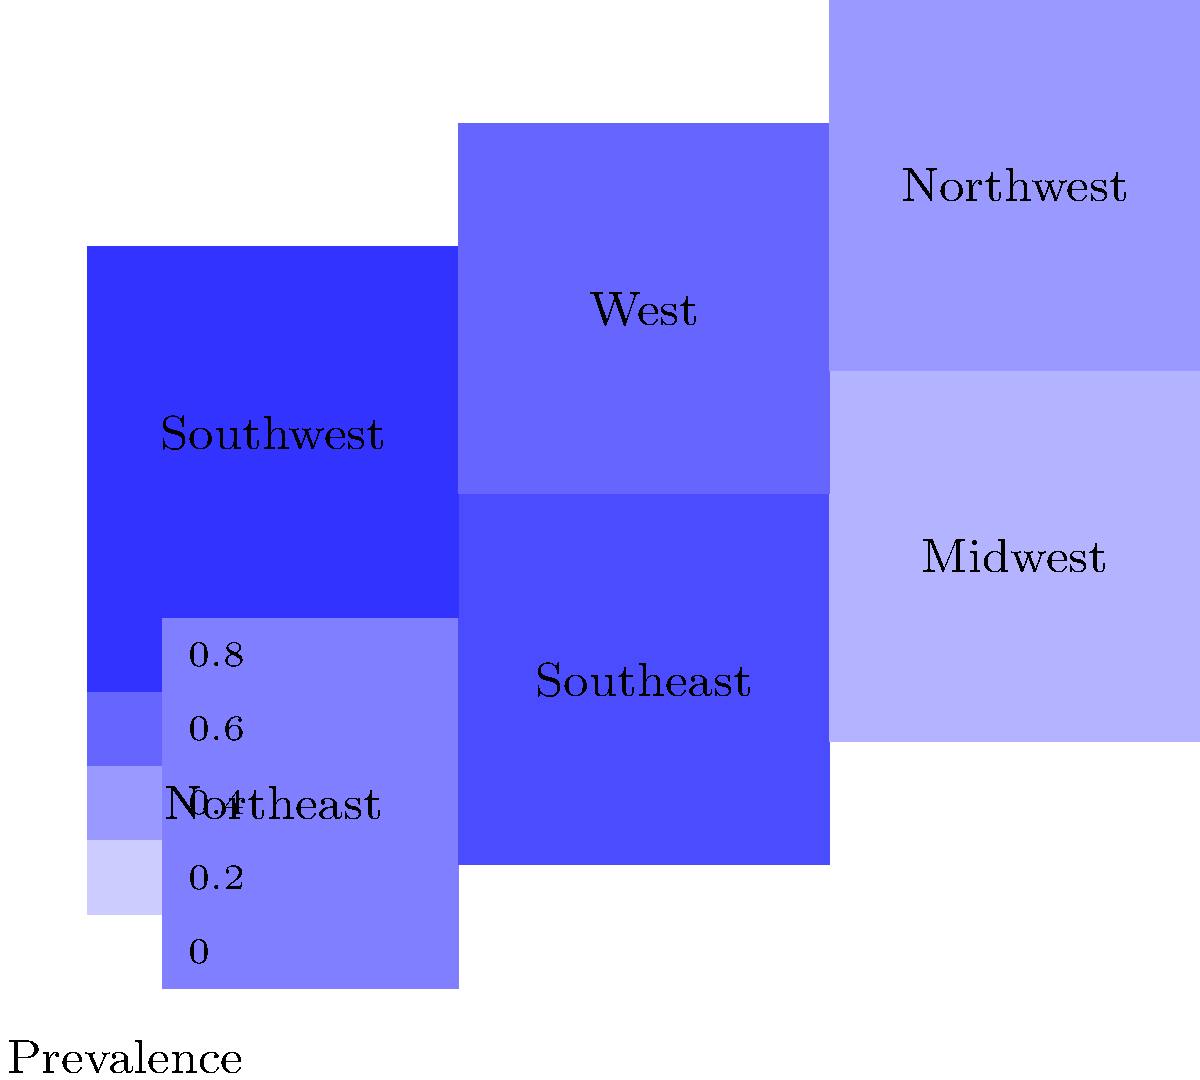Based on the heat map showing the prevalence of reported workplace discrimination cases by region, which area has the highest incidence of such cases? To determine the region with the highest prevalence of reported workplace discrimination cases, we need to analyze the heat map:

1. Understand the color coding: Darker shades of blue indicate higher prevalence of reported cases.
2. Examine each region:
   - Northeast: Moderate prevalence (medium blue)
   - Southeast: High prevalence (dark blue)
   - Midwest: Low prevalence (light blue)
   - Southwest: Highest prevalence (darkest blue)
   - West: Moderate to high prevalence (medium-dark blue)
   - Northwest: Low to moderate prevalence (light-medium blue)
3. Compare the shades: The Southwest region has the darkest shade of blue.
4. Consult the legend: The darkest blue corresponds to the highest value on the scale.

Therefore, the Southwest region has the highest incidence of reported workplace discrimination cases.
Answer: Southwest 